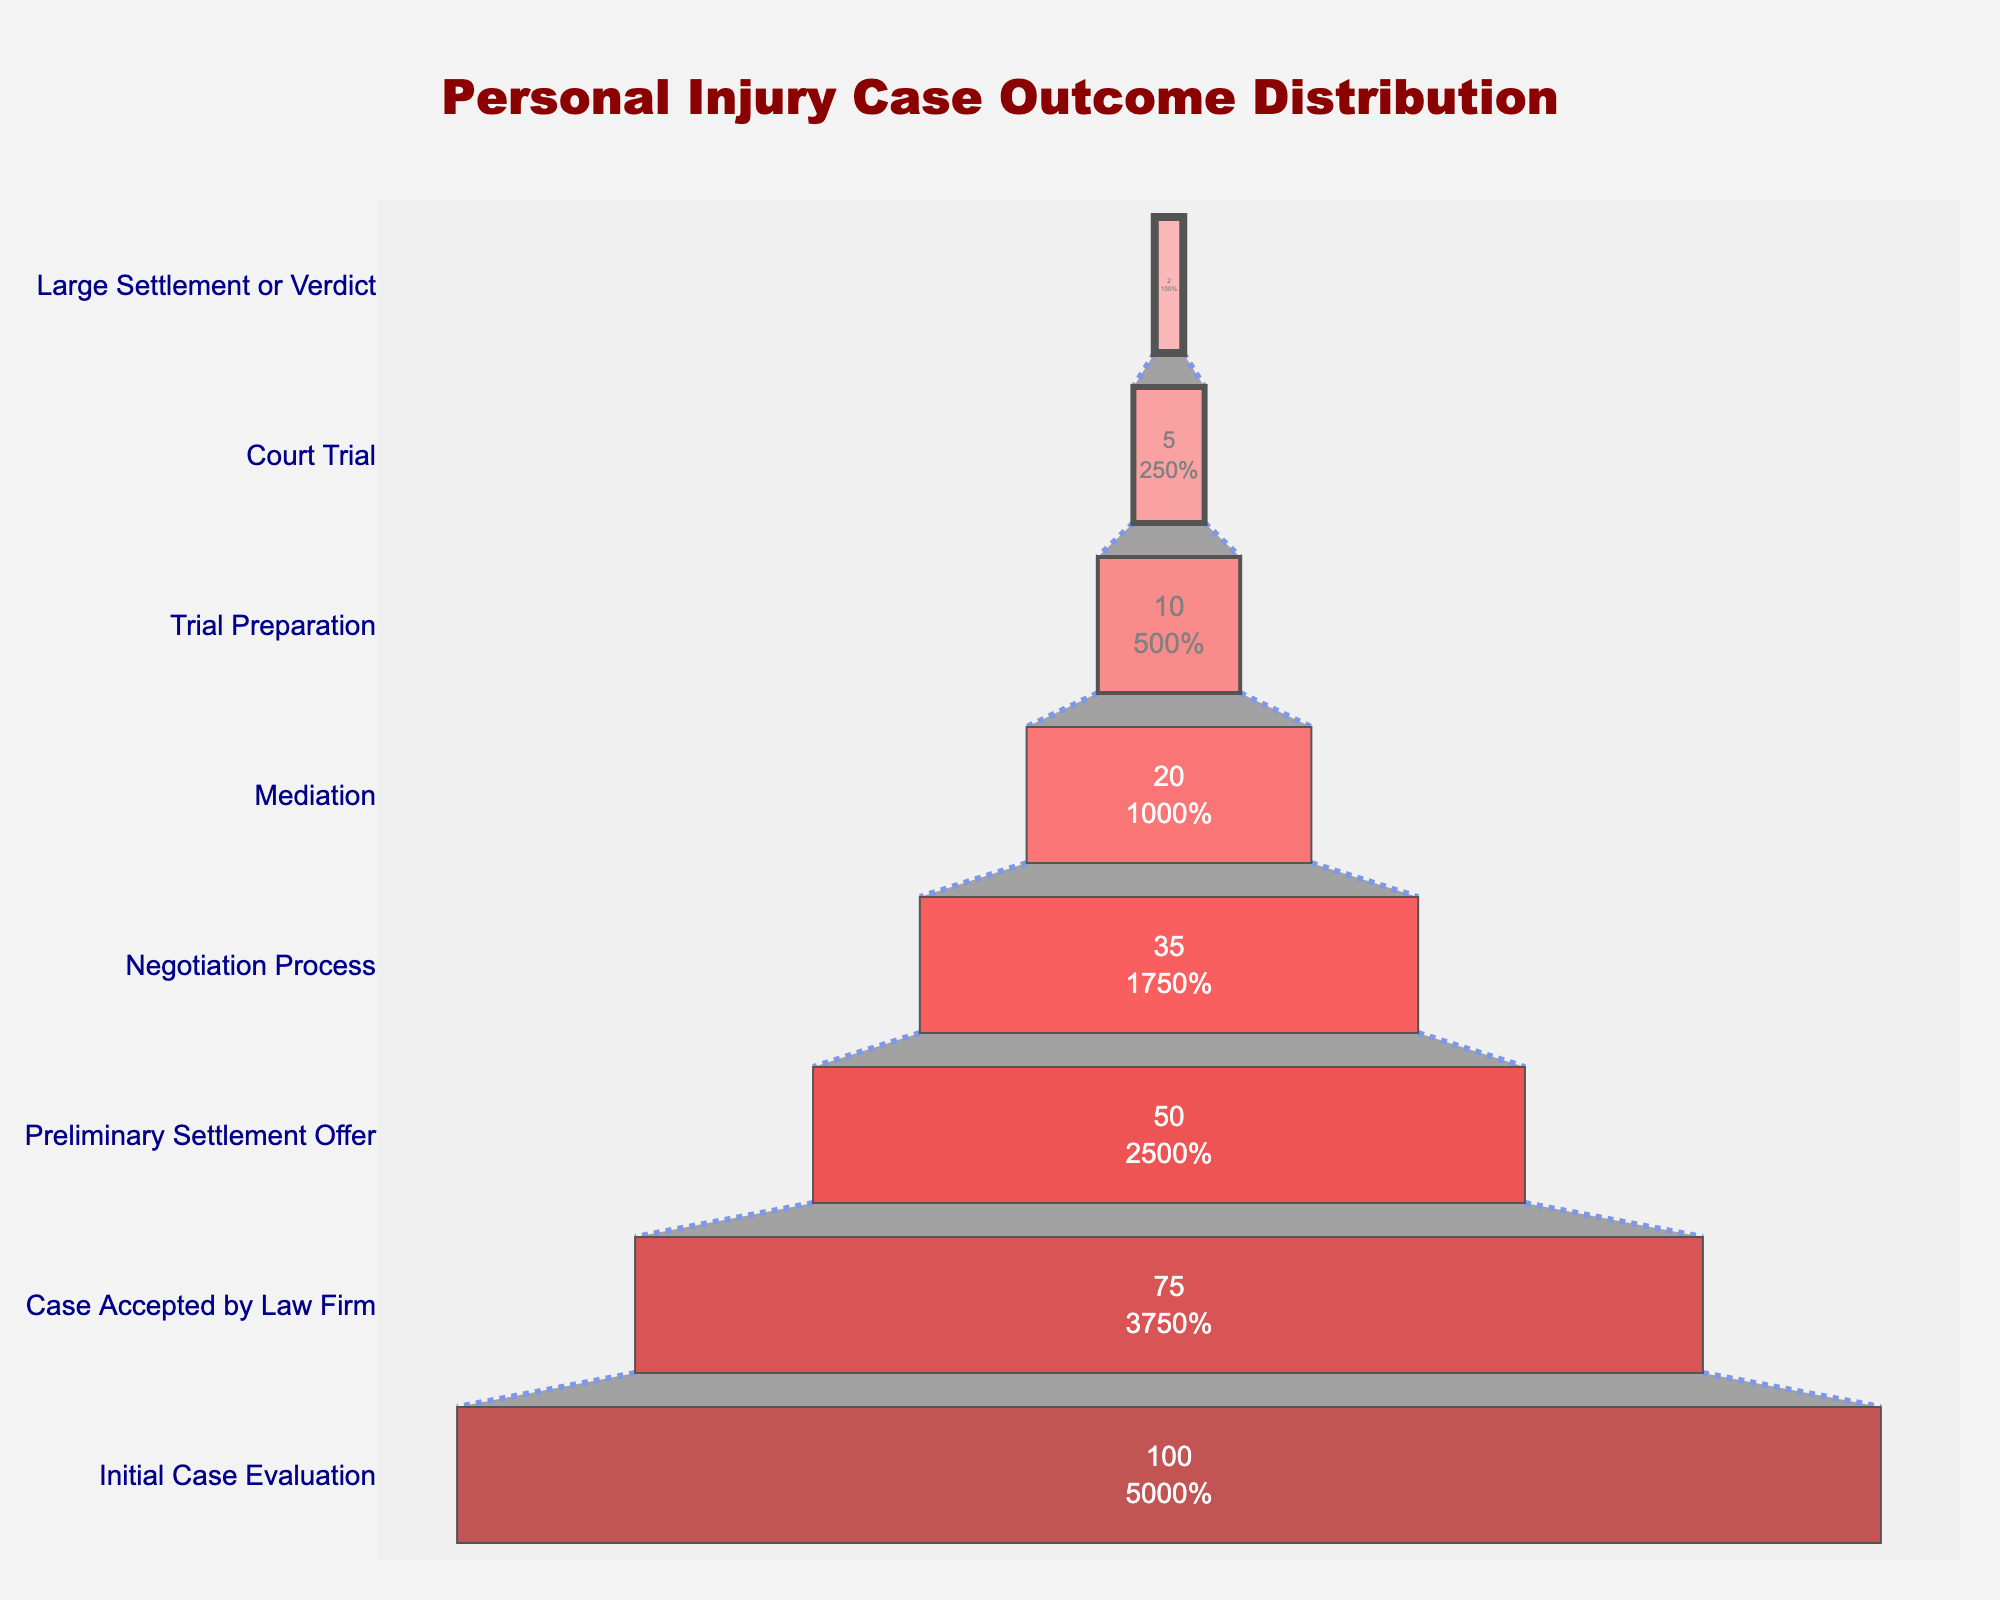What's the title of the funnel chart? The title of the funnel chart is located at the top center of the figure and reads "Personal Injury Case Outcome Distribution".
Answer: Personal Injury Case Outcome Distribution How many stages are depicted in the funnel chart? By looking at the y-axis, we can count the number of distinct stages labeled from top to bottom. There are 8 different stages listed.
Answer: 8 What is the percentage of cases that proceed to Mediation? The funnel chart shows each stage and its corresponding percentage. For Mediation, the percentage is marked next to the stage labeled "Mediation".
Answer: 20% Which stage immediately precedes the final stage "Large Settlement or Verdict"? The stage that appears just before "Large Settlement or Verdict" at the end of the funnel can be identified by tracing back one step on the y-axis. This stage is "Court Trial".
Answer: Court Trial What fraction of cases is accepted by the law firm out of the initial case evaluations? The percentage for the "Case Accepted by Law Firm" stage is 75%. The fraction can be calculated as 75/100.
Answer: 3/4 How many cases make it to the Trial Preparation stage? The funnel chart not only shows the percentage but also indicates the case count for each stage. For "Trial Preparation", the count is specified as 100.
Answer: 100 By how much does the percentage drop from the Initial Case Evaluation to the Preliminary Settlement Offer? The initial percentage is 100% and for the Preliminary Settlement Offer, it is 50%. So, the drop is calculated as 100% - 50% = 50%.
Answer: 50% What percentage of cases do not reach the Negotiation Process stage? To find the percentage of cases that do not reach the Negotiation Process stage, we look at the stage just before it, which is 50%. Subtracting this from 100%, we get 100% - 50% = 50%.
Answer: 50% Compare the number of cases at Mediation and Court Trial. Which has fewer cases? The case counts for Mediation and Court Trial are given as 200 and 50 respectively. By comparing these two numbers, Court Trial has fewer cases.
Answer: Court Trial 